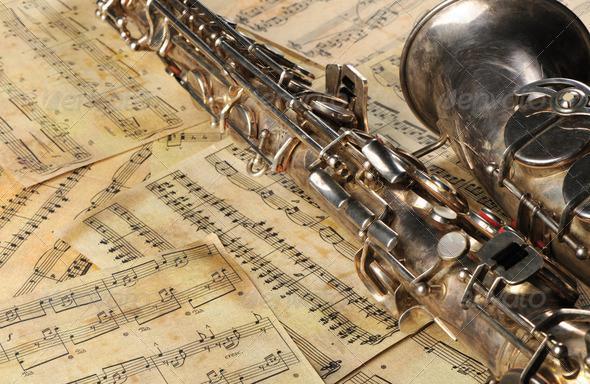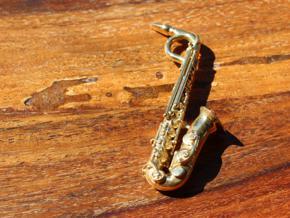The first image is the image on the left, the second image is the image on the right. Considering the images on both sides, is "An image shows an instrument laying flat on a woodgrain surface." valid? Answer yes or no. Yes. The first image is the image on the left, the second image is the image on the right. For the images shown, is this caption "One of the images shows the bell of a saxophone but not the mouth piece." true? Answer yes or no. Yes. 